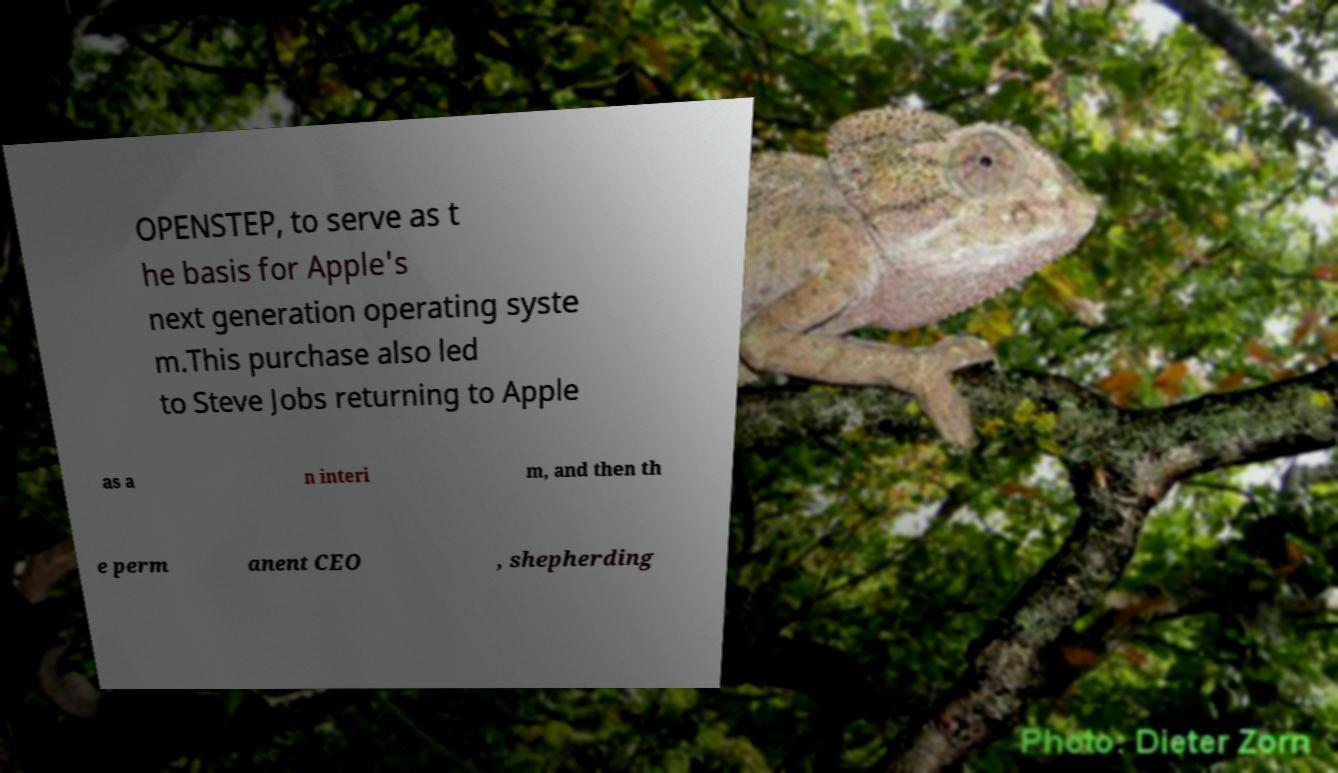Please identify and transcribe the text found in this image. OPENSTEP, to serve as t he basis for Apple's next generation operating syste m.This purchase also led to Steve Jobs returning to Apple as a n interi m, and then th e perm anent CEO , shepherding 